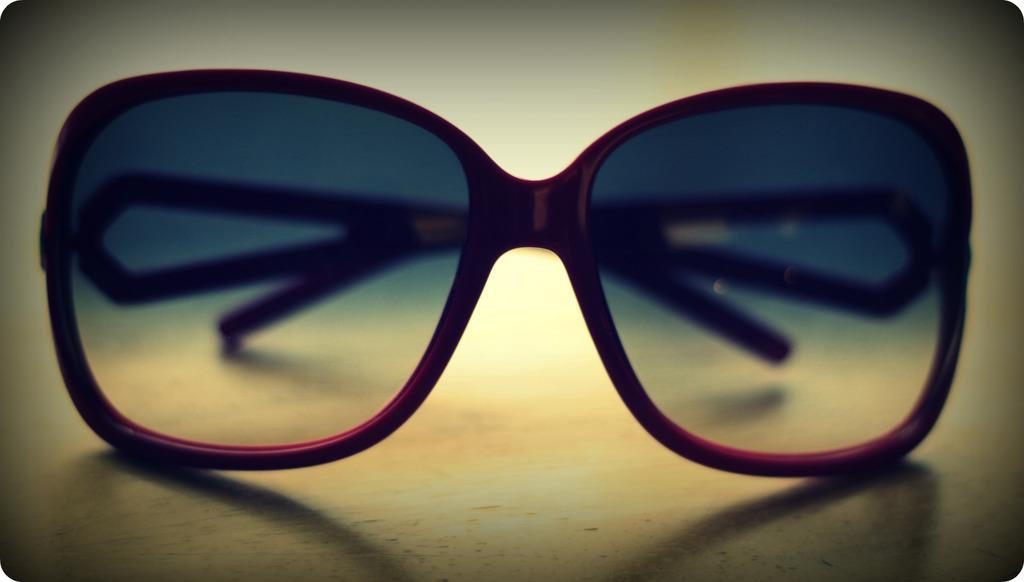What type of accessory is present in the image? There are sunglasses in the image. Where are the sunglasses located? The sunglasses are on a surface. What type of crib is visible in the image? There is no crib present in the image; it only features sunglasses on a surface. 